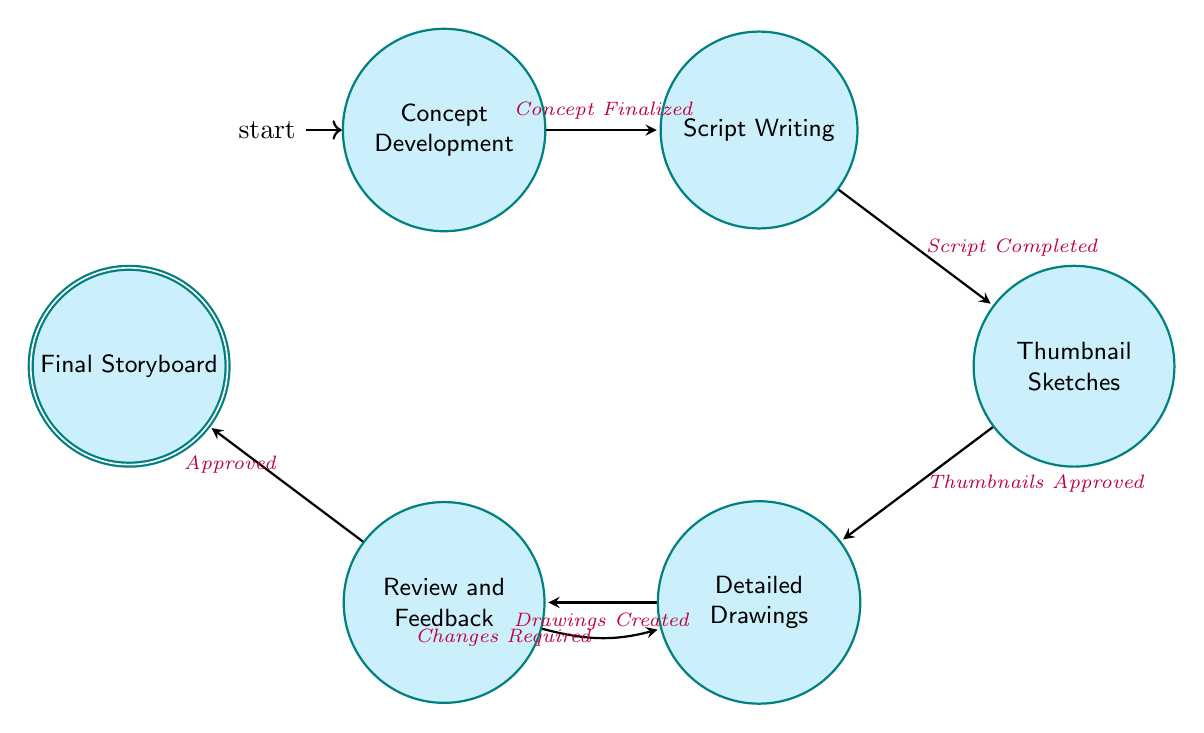What is the initial state in the diagram? The initial state is indicated by the arrow pointing to the state. In this case, "Concept Development" is the first state because it is where the process begins.
Answer: Concept Development How many total states are represented in the diagram? By counting each labeled state node in the diagram, we find six unique states: Concept Development, Script Writing, Thumbnail Sketches, Detailed Drawings, Review and Feedback, and Final Storyboard.
Answer: 6 What transition occurs after "Thumbnail Sketches"? The transition labeled "Thumbnails Approved" is the one that follows "Thumbnail Sketches," leading to the next state, which is "Detailed Drawings."
Answer: Detailed Drawings Which state directly leads to "Final Storyboard"? The direct path to "Final Storyboard" comes from the "Review and Feedback" state, as shown by the arrow leading to "Final Storyboard" that is labeled "Approved."
Answer: Review and Feedback What happens if "Changes Required" are identified during the "Review and Feedback" stage? If "Changes Required" are identified, the process transitions back to the "Detailed Drawings" state, indicating revisions are needed.
Answer: Detailed Drawings How is "Script Writing" reached from its previous state? "Script Writing" is reached from "Concept Development" when the transition labeled "Concept Finalized" is completed. This shows the progression from idea to script.
Answer: Script Writing What is the last state in the process? The last state is highlighted as the final output of the diagram process, which is "Final Storyboard." This represents the end point where the storyboard is finalized and ready for production.
Answer: Final Storyboard Which two states can lead to the "Review and Feedback" state? The "Detailed Drawings" state always leads to "Review and Feedback" with the transition labeled "Drawings Created," while if changes are needed, it loops back again as indicated by "Changes Required."
Answer: Detailed Drawings and Review and Feedback 